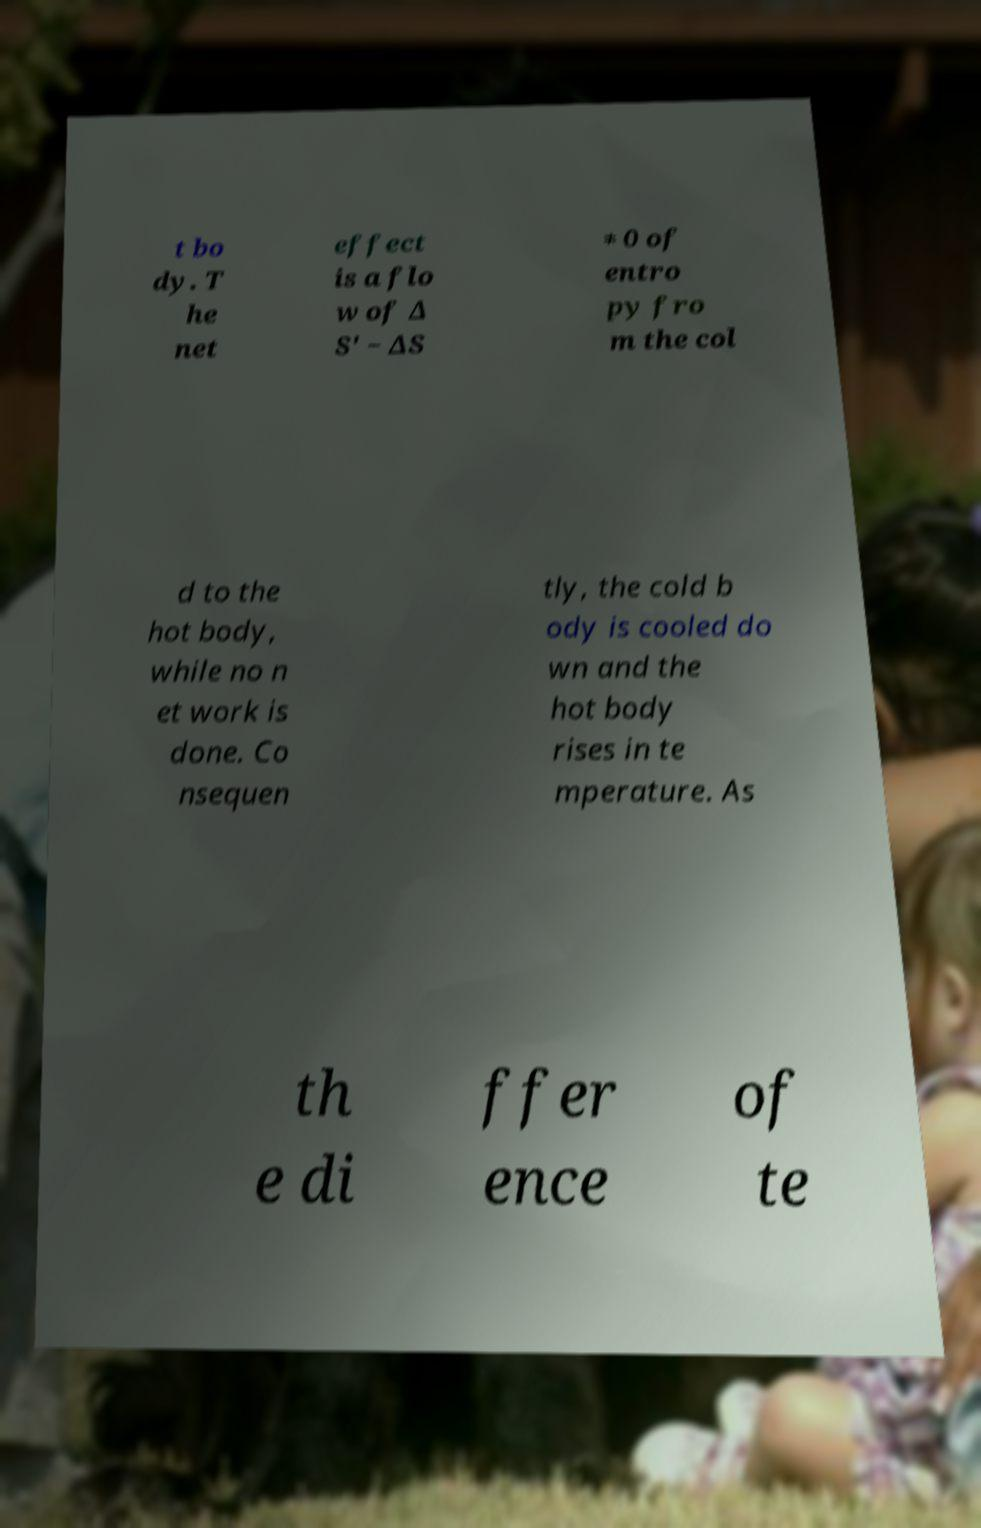For documentation purposes, I need the text within this image transcribed. Could you provide that? t bo dy. T he net effect is a flo w of ∆ S' − ∆S ≠ 0 of entro py fro m the col d to the hot body, while no n et work is done. Co nsequen tly, the cold b ody is cooled do wn and the hot body rises in te mperature. As th e di ffer ence of te 